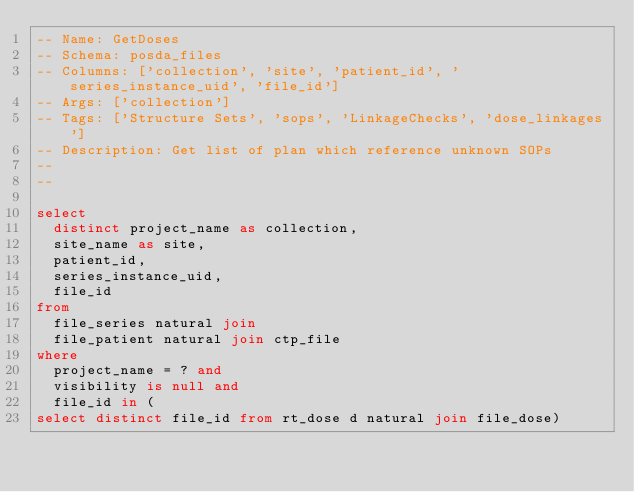<code> <loc_0><loc_0><loc_500><loc_500><_SQL_>-- Name: GetDoses
-- Schema: posda_files
-- Columns: ['collection', 'site', 'patient_id', 'series_instance_uid', 'file_id']
-- Args: ['collection']
-- Tags: ['Structure Sets', 'sops', 'LinkageChecks', 'dose_linkages']
-- Description: Get list of plan which reference unknown SOPs
-- 
-- 

select
  distinct project_name as collection,
  site_name as site,
  patient_id,
  series_instance_uid,
  file_id
from
  file_series natural join
  file_patient natural join ctp_file
where
  project_name = ? and
  visibility is null and
  file_id in (
select distinct file_id from rt_dose d natural join file_dose)</code> 